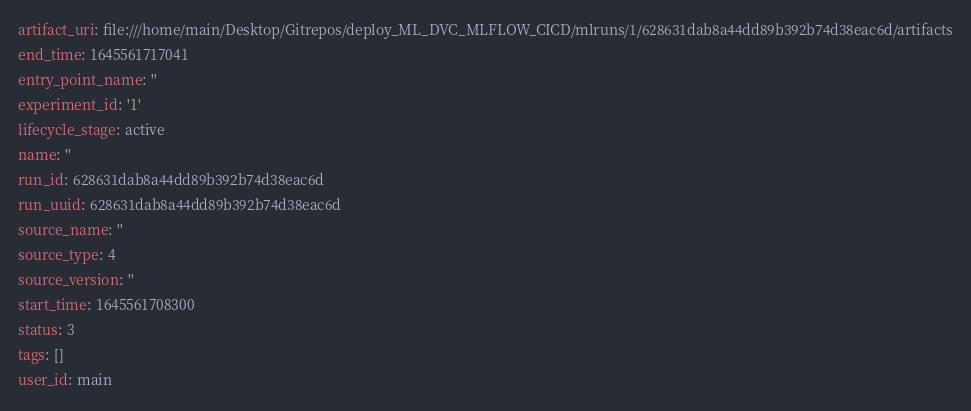Convert code to text. <code><loc_0><loc_0><loc_500><loc_500><_YAML_>artifact_uri: file:///home/main/Desktop/Gitrepos/deploy_ML_DVC_MLFLOW_CICD/mlruns/1/628631dab8a44dd89b392b74d38eac6d/artifacts
end_time: 1645561717041
entry_point_name: ''
experiment_id: '1'
lifecycle_stage: active
name: ''
run_id: 628631dab8a44dd89b392b74d38eac6d
run_uuid: 628631dab8a44dd89b392b74d38eac6d
source_name: ''
source_type: 4
source_version: ''
start_time: 1645561708300
status: 3
tags: []
user_id: main
</code> 